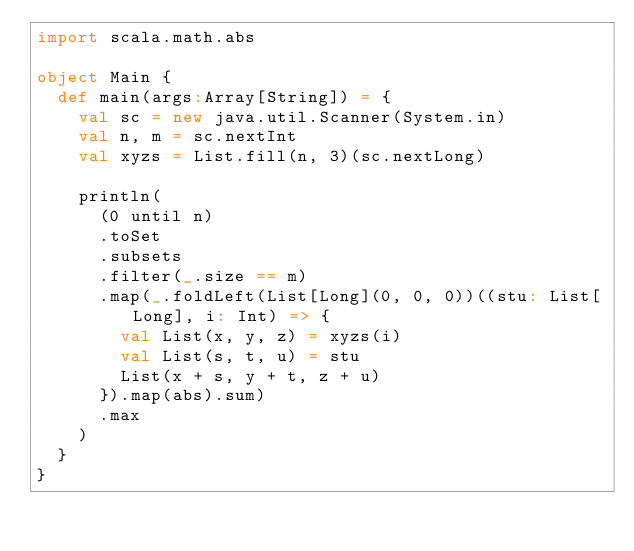<code> <loc_0><loc_0><loc_500><loc_500><_Scala_>import scala.math.abs

object Main {
  def main(args:Array[String]) = {
    val sc = new java.util.Scanner(System.in)
    val n, m = sc.nextInt
    val xyzs = List.fill(n, 3)(sc.nextLong)

    println(
      (0 until n)
      .toSet
      .subsets
      .filter(_.size == m)
      .map(_.foldLeft(List[Long](0, 0, 0))((stu: List[Long], i: Int) => {
        val List(x, y, z) = xyzs(i)
        val List(s, t, u) = stu
        List(x + s, y + t, z + u)
      }).map(abs).sum)
      .max
    )
  }
}
</code> 